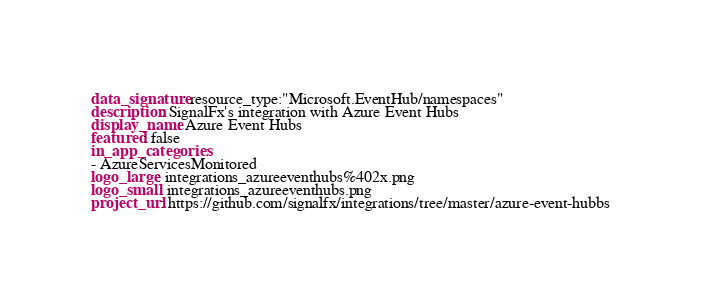<code> <loc_0><loc_0><loc_500><loc_500><_YAML_>data_signature: resource_type:"Microsoft.EventHub/namespaces"
description: SignalFx's integration with Azure Event Hubs
display_name: Azure Event Hubs
featured: false
in_app_categories:
- AzureServicesMonitored
logo_large: integrations_azureeventhubs%402x.png
logo_small: integrations_azureeventhubs.png
project_url: https://github.com/signalfx/integrations/tree/master/azure-event-hubbs
</code> 